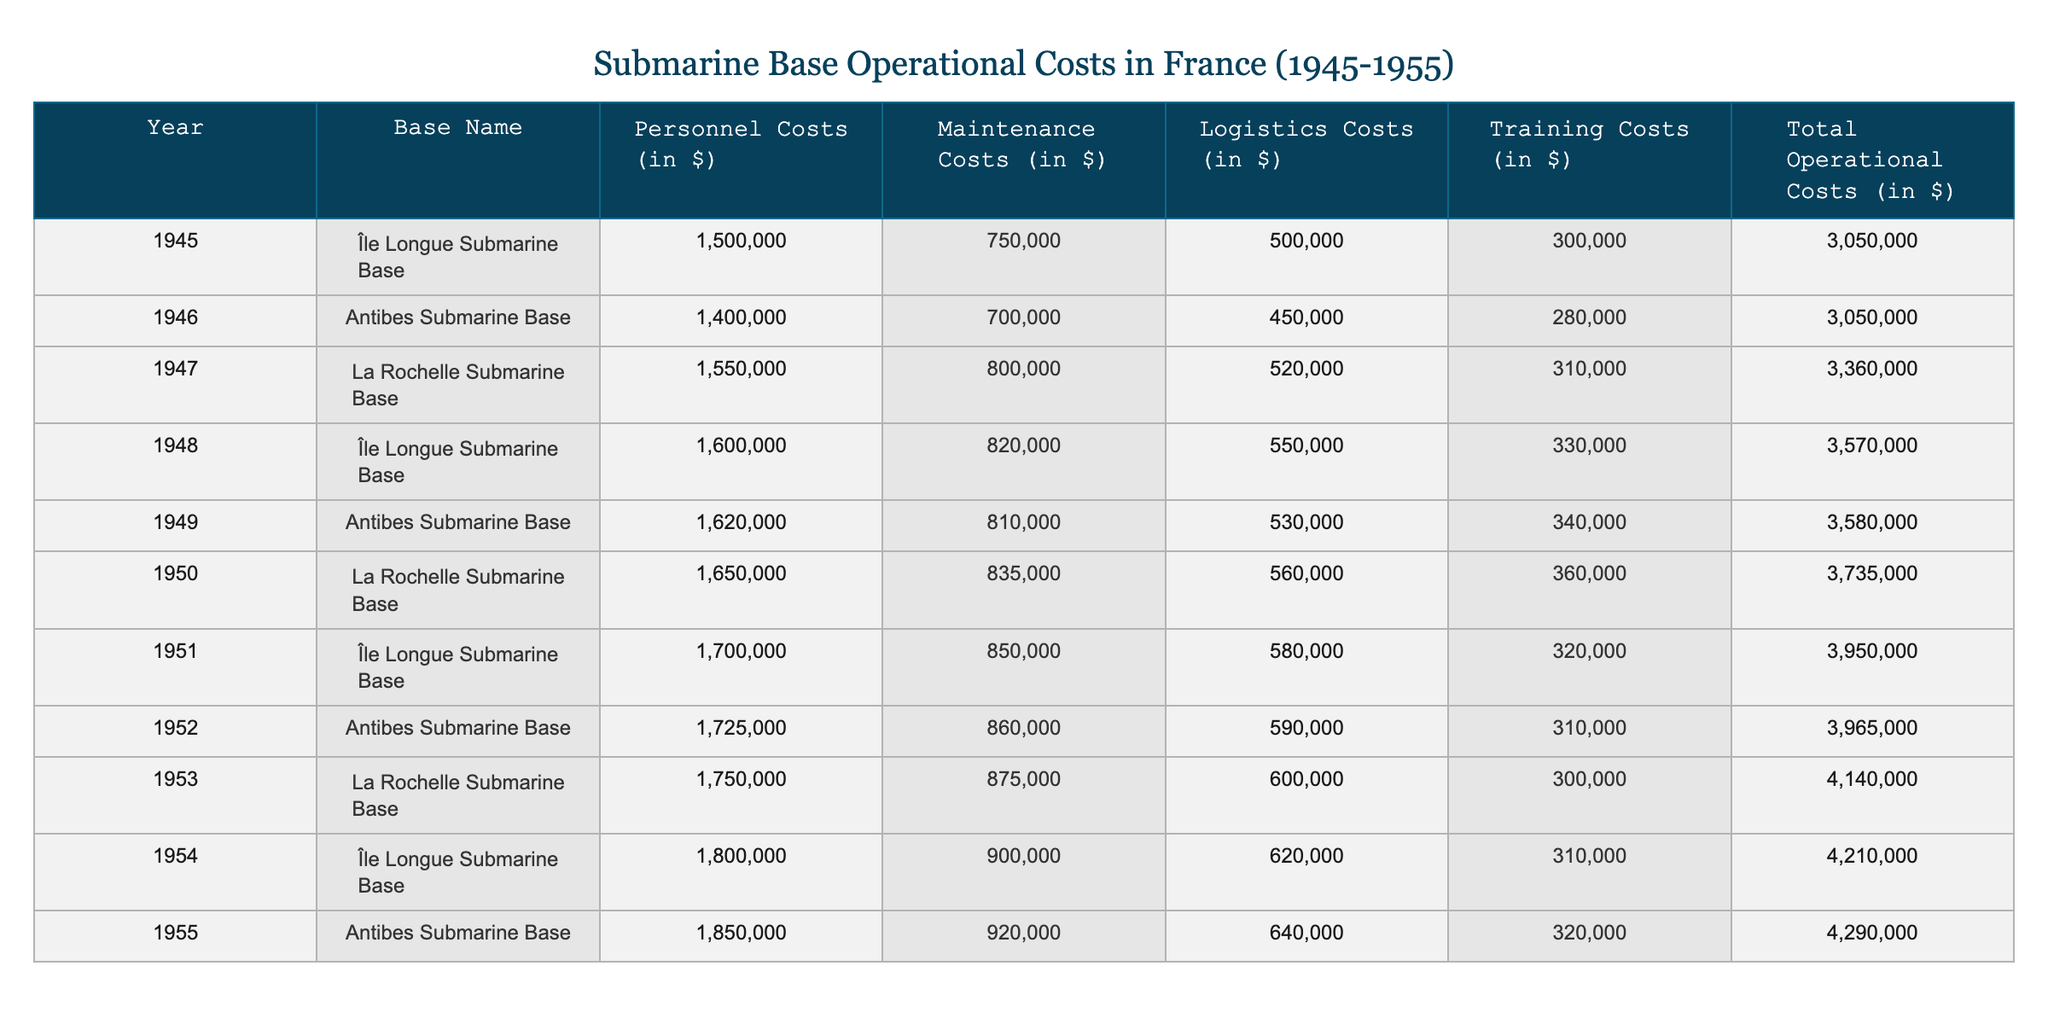What was the total operational cost for the Île Longue Submarine Base in 1954? The table shows that the total operational cost for the Île Longue Submarine Base in 1954 is **$4,210,000**.
Answer: $4,210,000 Which base had the highest personnel costs in 1953? By examining the table, we can see that the personnel costs for La Rochelle Submarine Base in 1953 were **$1,750,000**, which is the highest among all bases for that year.
Answer: $1,750,000 What was the average maintenance cost from 1945 to 1955? First, we gather the maintenance costs for each year: $750,000 (1945), $700,000 (1946), $800,000 (1947), $820,000 (1948), $810,000 (1949), $835,000 (1950), $850,000 (1951), $860,000 (1952), $875,000 (1953), $900,000 (1954), $920,000 (1955). The total is $9,520,000, and since there are 11 years, the average is $9,520,000 ÷ 11 ≈ $866,364.
Answer: $866,364 Did the total operational costs increase every year from 1945 to 1955? By checking the total operational costs for each year, we observe an increase from the first year (1945) to the last (1955), affirming that costs rose consistently during this period.
Answer: Yes What was the percentage increase in total operational costs from 1945 to 1955? The total operational cost in 1945 is $3,050,000 and in 1955 it’s $4,290,000. The increase is $4,290,000 - $3,050,000 = $1,240,000. To find the percentage increase, we divide the increase by the original amount: ($1,240,000 ÷ $3,050,000) × 100 ≈ 40.66%.
Answer: 40.66% What are the logistics costs for Antibes Submarine Base in 1949 and how do they compare to 1954? The logistics cost for Antibes in 1949 is $530,000 and in 1954 it's $640,000. The difference is $640,000 - $530,000 = $110,000, showing that logistics costs increased year over year for this base.
Answer: $530,000 (1949), $640,000 (1954), difference $110,000 Which base had the lowest total operational costs in the entire period? By reviewing the total operational costs for each base in every year, we find that the lowest total was in 1945 for the Île Longue Submarine Base with **$3,050,000**.
Answer: $3,050,000 What was the training cost for La Rochelle Submarine Base in 1950, and how does it compare to Antibes Submarine Base in 1952? The training cost for La Rochelle in 1950 is $360,000, while for Antibes in 1952, it is $310,000. Comparing these values, La Rochelle's cost is higher by $360,000 - $310,000 = $50,000.
Answer: $360,000 (La Rochelle 1950); $310,000 (Antibes 1952); higher by $50,000 